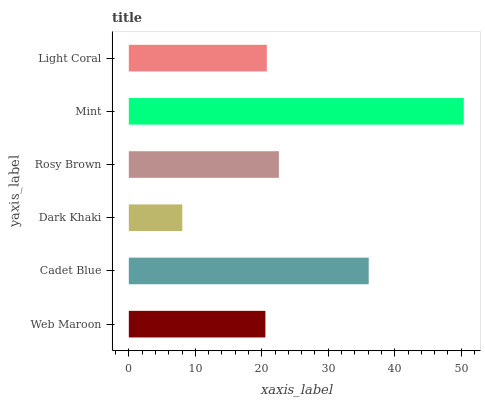Is Dark Khaki the minimum?
Answer yes or no. Yes. Is Mint the maximum?
Answer yes or no. Yes. Is Cadet Blue the minimum?
Answer yes or no. No. Is Cadet Blue the maximum?
Answer yes or no. No. Is Cadet Blue greater than Web Maroon?
Answer yes or no. Yes. Is Web Maroon less than Cadet Blue?
Answer yes or no. Yes. Is Web Maroon greater than Cadet Blue?
Answer yes or no. No. Is Cadet Blue less than Web Maroon?
Answer yes or no. No. Is Rosy Brown the high median?
Answer yes or no. Yes. Is Light Coral the low median?
Answer yes or no. Yes. Is Light Coral the high median?
Answer yes or no. No. Is Mint the low median?
Answer yes or no. No. 